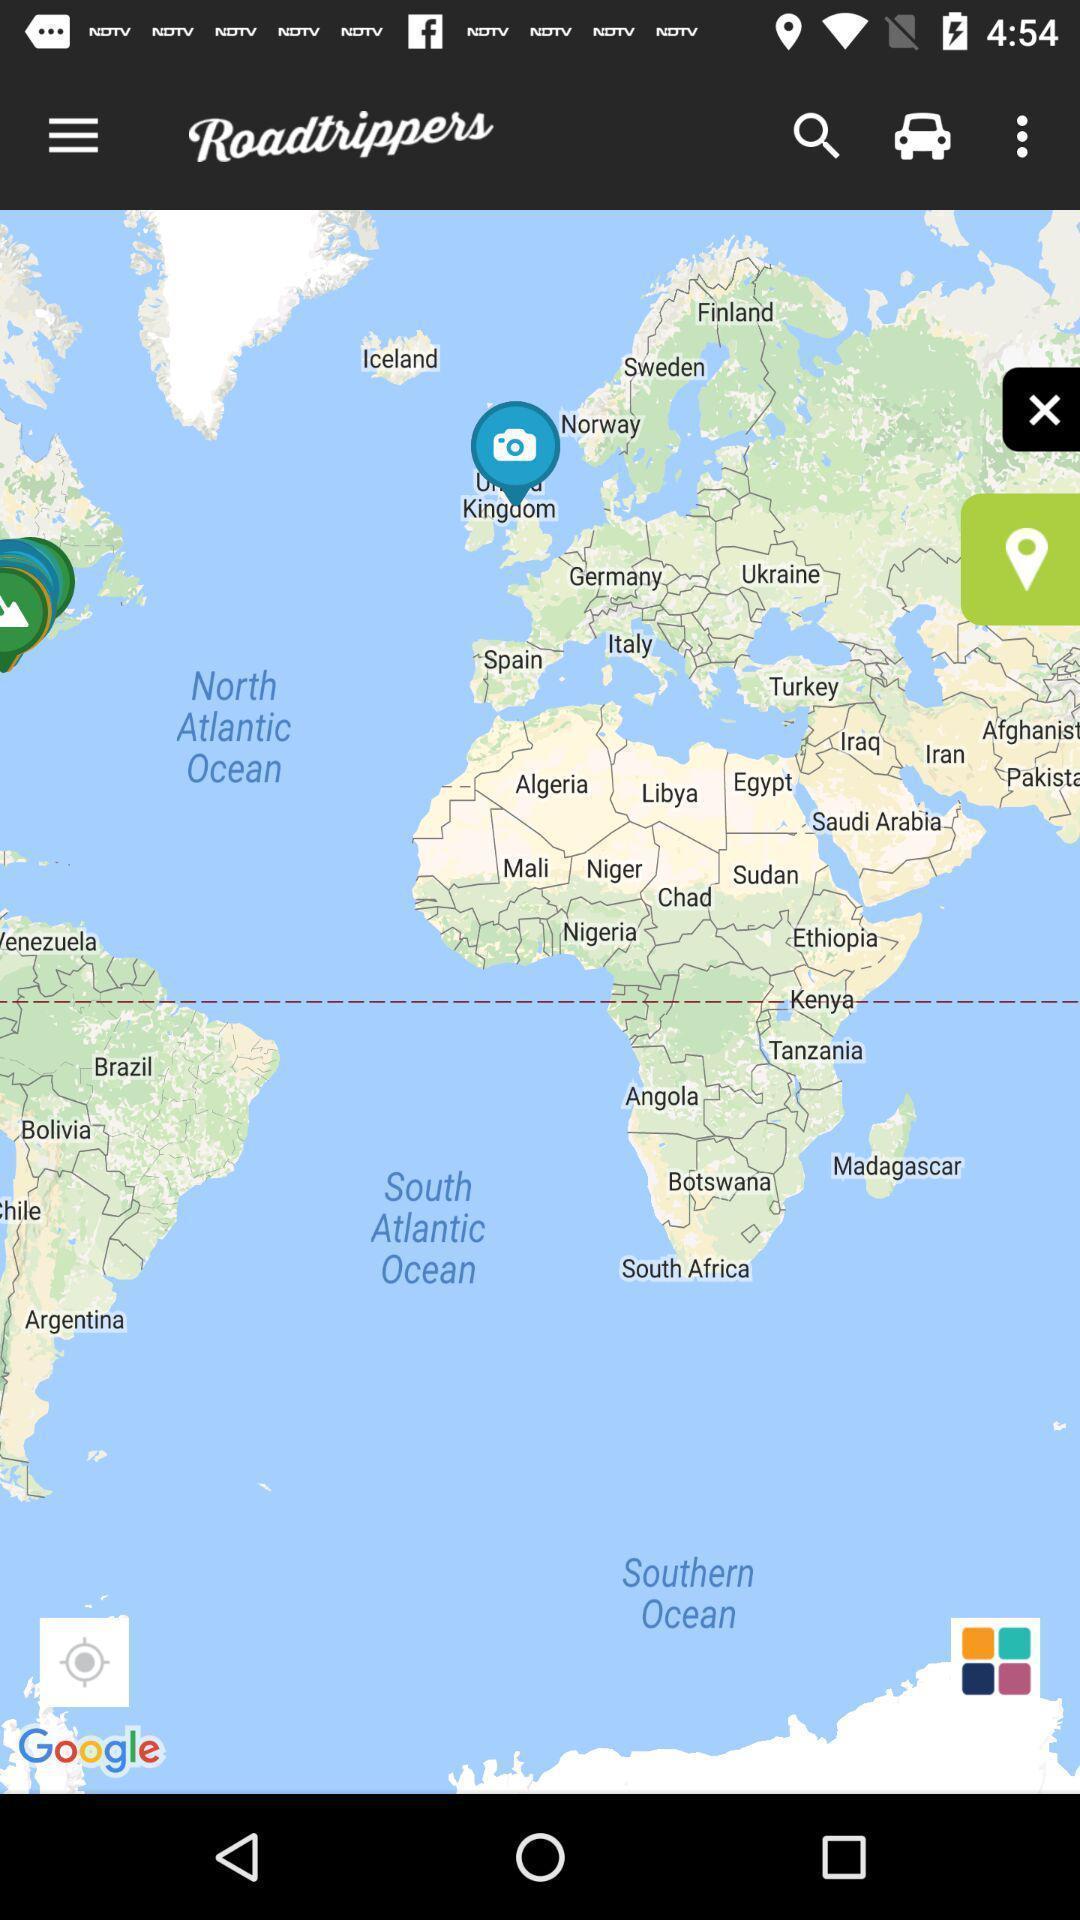Provide a detailed account of this screenshot. Page that displaying gps application. 